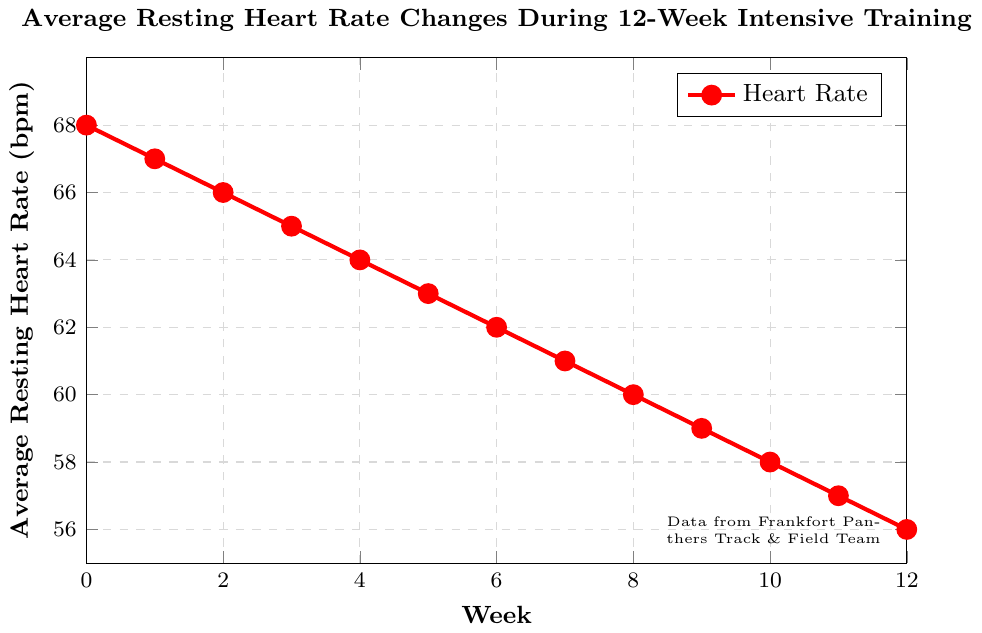What is the average resting heart rate at week 6? Let's locate week 6 on the x-axis and find the corresponding value on the y-axis. The chart shows an average resting heart rate of 62 bpm at week 6.
Answer: 62 bpm How much did the average resting heart rate decrease between week 0 and week 8? At week 0, the heart rate is 68 bpm, and at week 8, it is 60 bpm. The decrease is calculated as 68 - 60 = 8 bpm.
Answer: 8 bpm What is the total decrease in average resting heart rate from the start to the end of the 12-week program? At week 0, the heart rate is 68 bpm, and at week 12, it is 56 bpm. The total decrease is 68 - 56 = 12 bpm.
Answer: 12 bpm At which week does the average resting heart rate first drop below 60 bpm? We need to check when the heart rate first goes below 60 bpm. Observing the full timeline, it first drops to 59 bpm at week 9.
Answer: Week 9 Is the rate of decrease in average resting heart rate constant throughout the 12-week period? We observe the plot. Each week, the heart rate decreases by 1 bpm, showing a consistent rate of decrease.
Answer: Yes What is the average resting heart rate at the midpoint (week 6) and at the end (week 12)? At week 6, it's 62 bpm, and at week 12, it's 56 bpm according to the plotted values.
Answer: 62 bpm and 56 bpm Compare the rate of decrease in heart rate between the first 4 weeks and the last 4 weeks. Which period has a higher rate of decrease? In the first 4 weeks, the heart rate decreases from 68 to 64 bpm, a total of 4 bpm. In the last 4 weeks, it decreases from 60 to 56 bpm, a total of 4 bpm. The rate of decrease is equal in both periods (1 bpm per week).
Answer: Equal What is the difference in average resting heart rate between week 3 and week 5? At week 3, the heart rate is 65 bpm, and at week 5, it is 63 bpm. The difference is 65 - 63 = 2 bpm.
Answer: 2 bpm What is the lowest average resting heart rate recorded during the program? The lowest heart rate is observed at the end of the program at week 12, which is 56 bpm.
Answer: 56 bpm UESTION7: Compare the average resting heart rate at week 2 and week 10. The heart rate at week 2 is 66 bpm, and at week 10, it is 58 bpm. Therefore, the rate at week 2 is higher by 66 - 58 = 8 bpm.
Answer: Week 2's heart rate is 8 bpm higher 